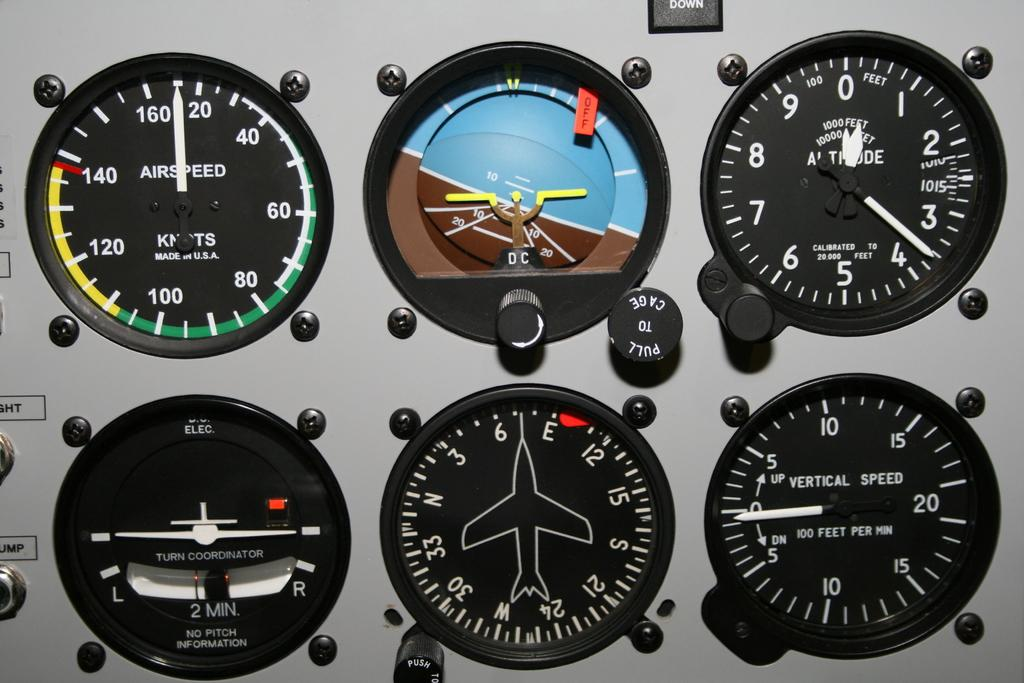<image>
Give a short and clear explanation of the subsequent image. One of the buttons on a control panel is marked with Pull to Cage. 